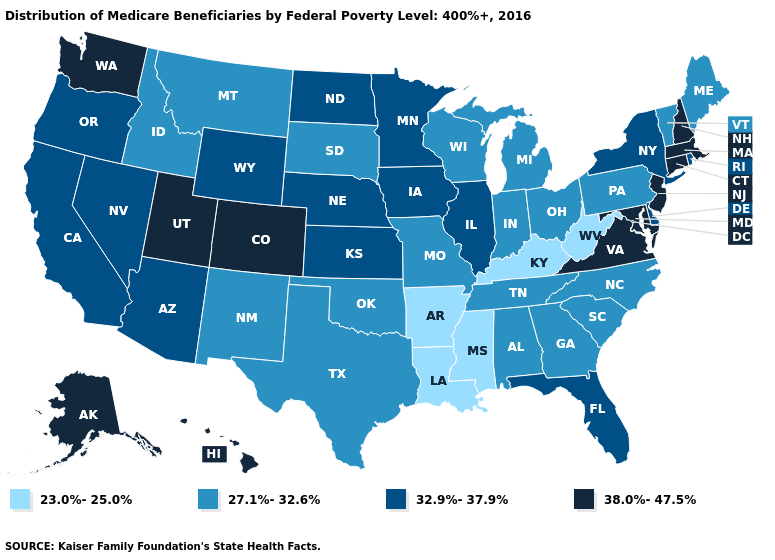What is the highest value in the USA?
Write a very short answer. 38.0%-47.5%. What is the highest value in the USA?
Answer briefly. 38.0%-47.5%. What is the value of Ohio?
Give a very brief answer. 27.1%-32.6%. Does Kansas have the highest value in the USA?
Short answer required. No. Does the map have missing data?
Be succinct. No. Does the map have missing data?
Give a very brief answer. No. Name the states that have a value in the range 32.9%-37.9%?
Keep it brief. Arizona, California, Delaware, Florida, Illinois, Iowa, Kansas, Minnesota, Nebraska, Nevada, New York, North Dakota, Oregon, Rhode Island, Wyoming. What is the value of Delaware?
Short answer required. 32.9%-37.9%. What is the value of Wisconsin?
Concise answer only. 27.1%-32.6%. What is the value of Montana?
Answer briefly. 27.1%-32.6%. Which states hav the highest value in the Northeast?
Short answer required. Connecticut, Massachusetts, New Hampshire, New Jersey. What is the value of Nebraska?
Be succinct. 32.9%-37.9%. Which states have the highest value in the USA?
Be succinct. Alaska, Colorado, Connecticut, Hawaii, Maryland, Massachusetts, New Hampshire, New Jersey, Utah, Virginia, Washington. Does Arkansas have a lower value than Wyoming?
Concise answer only. Yes. Does Maine have the lowest value in the Northeast?
Keep it brief. Yes. 